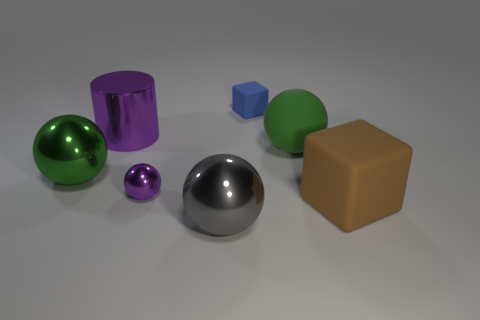The thing that is behind the big brown block and to the right of the blue object is made of what material? The object behind the big brown block and to the right of the blue object appears to have a shiny surface, suggesting it is made of a polished material such as metal or plastic, not rubber as was previously mentioned. 